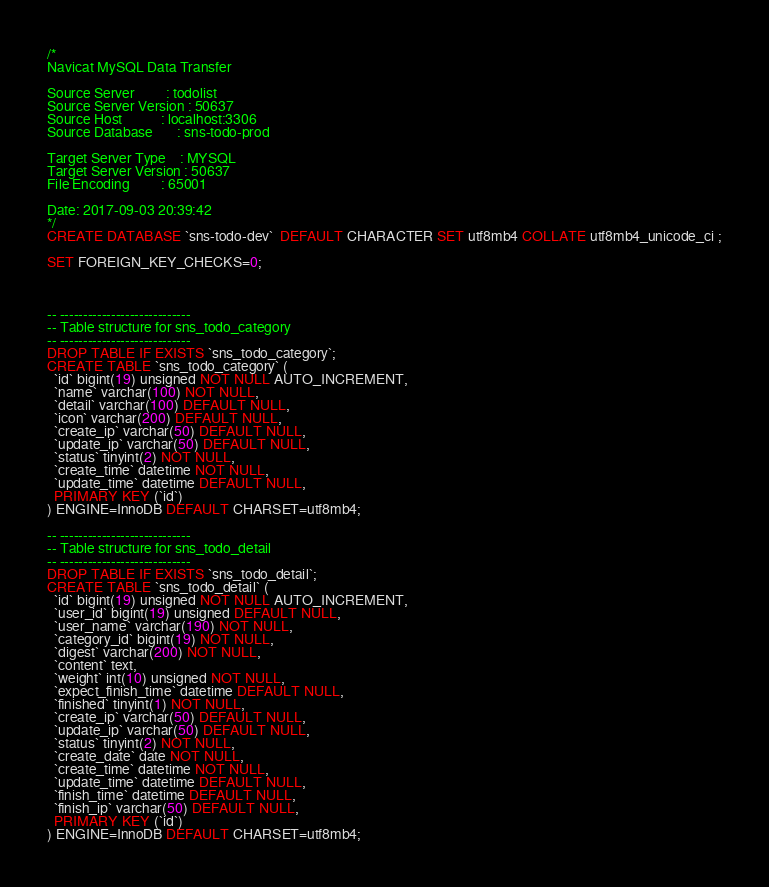Convert code to text. <code><loc_0><loc_0><loc_500><loc_500><_SQL_>/*
Navicat MySQL Data Transfer

Source Server         : todolist
Source Server Version : 50637
Source Host           : localhost:3306
Source Database       : sns-todo-prod

Target Server Type    : MYSQL
Target Server Version : 50637
File Encoding         : 65001

Date: 2017-09-03 20:39:42
*/
CREATE DATABASE `sns-todo-dev`  DEFAULT CHARACTER SET utf8mb4 COLLATE utf8mb4_unicode_ci ;

SET FOREIGN_KEY_CHECKS=0;



-- ----------------------------
-- Table structure for sns_todo_category
-- ----------------------------
DROP TABLE IF EXISTS `sns_todo_category`;
CREATE TABLE `sns_todo_category` (
  `id` bigint(19) unsigned NOT NULL AUTO_INCREMENT,
  `name` varchar(100) NOT NULL,
  `detail` varchar(100) DEFAULT NULL,
  `icon` varchar(200) DEFAULT NULL,
  `create_ip` varchar(50) DEFAULT NULL,
  `update_ip` varchar(50) DEFAULT NULL,
  `status` tinyint(2) NOT NULL,
  `create_time` datetime NOT NULL,
  `update_time` datetime DEFAULT NULL,
  PRIMARY KEY (`id`)
) ENGINE=InnoDB DEFAULT CHARSET=utf8mb4;

-- ----------------------------
-- Table structure for sns_todo_detail
-- ----------------------------
DROP TABLE IF EXISTS `sns_todo_detail`;
CREATE TABLE `sns_todo_detail` (
  `id` bigint(19) unsigned NOT NULL AUTO_INCREMENT,
  `user_id` bigint(19) unsigned DEFAULT NULL,
  `user_name` varchar(190) NOT NULL,
  `category_id` bigint(19) NOT NULL,
  `digest` varchar(200) NOT NULL,
  `content` text,
  `weight` int(10) unsigned NOT NULL,
  `expect_finish_time` datetime DEFAULT NULL,
  `finished` tinyint(1) NOT NULL,
  `create_ip` varchar(50) DEFAULT NULL,
  `update_ip` varchar(50) DEFAULT NULL,
  `status` tinyint(2) NOT NULL,
  `create_date` date NOT NULL,
  `create_time` datetime NOT NULL,
  `update_time` datetime DEFAULT NULL,
  `finish_time` datetime DEFAULT NULL,
  `finish_ip` varchar(50) DEFAULT NULL,
  PRIMARY KEY (`id`)
) ENGINE=InnoDB DEFAULT CHARSET=utf8mb4;
</code> 